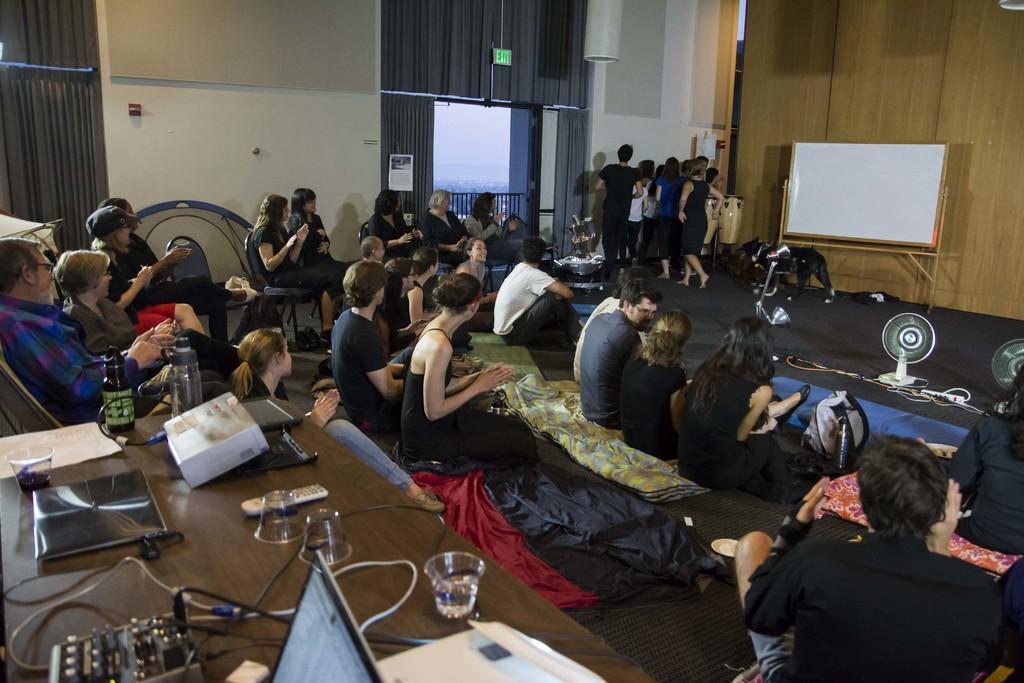Describe this image in one or two sentences. Some people are watching a performance given by a set of performers. 